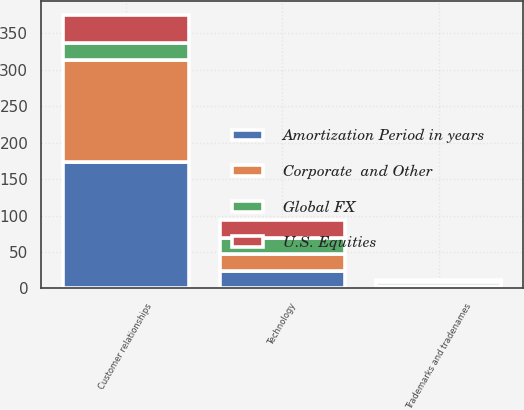Convert chart. <chart><loc_0><loc_0><loc_500><loc_500><stacked_bar_chart><ecel><fcel>Customer relationships<fcel>Technology<fcel>Trademarks and tradenames<nl><fcel>U.S. Equities<fcel>38.8<fcel>24.6<fcel>1.7<nl><fcel>Global FX<fcel>22.5<fcel>22.5<fcel>6<nl><fcel>Amortization Period in years<fcel>173.7<fcel>24.4<fcel>2<nl><fcel>Corporate  and Other<fcel>140<fcel>22.5<fcel>1.2<nl></chart> 